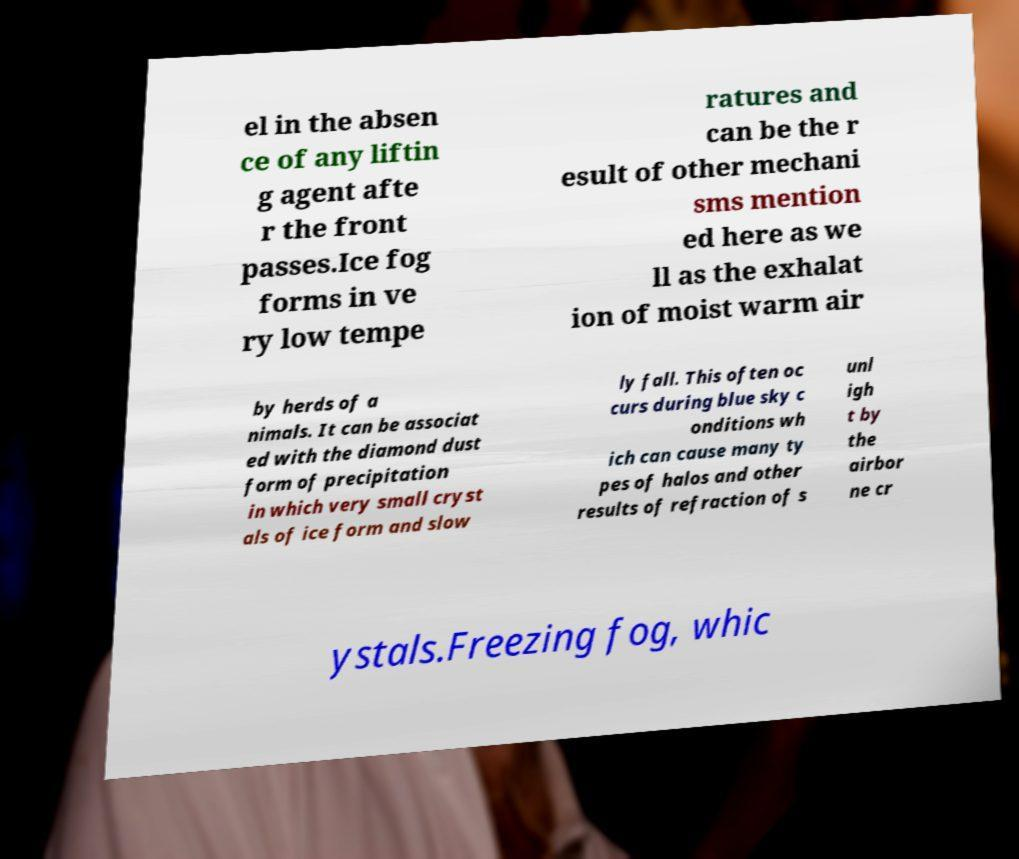I need the written content from this picture converted into text. Can you do that? el in the absen ce of any liftin g agent afte r the front passes.Ice fog forms in ve ry low tempe ratures and can be the r esult of other mechani sms mention ed here as we ll as the exhalat ion of moist warm air by herds of a nimals. It can be associat ed with the diamond dust form of precipitation in which very small cryst als of ice form and slow ly fall. This often oc curs during blue sky c onditions wh ich can cause many ty pes of halos and other results of refraction of s unl igh t by the airbor ne cr ystals.Freezing fog, whic 